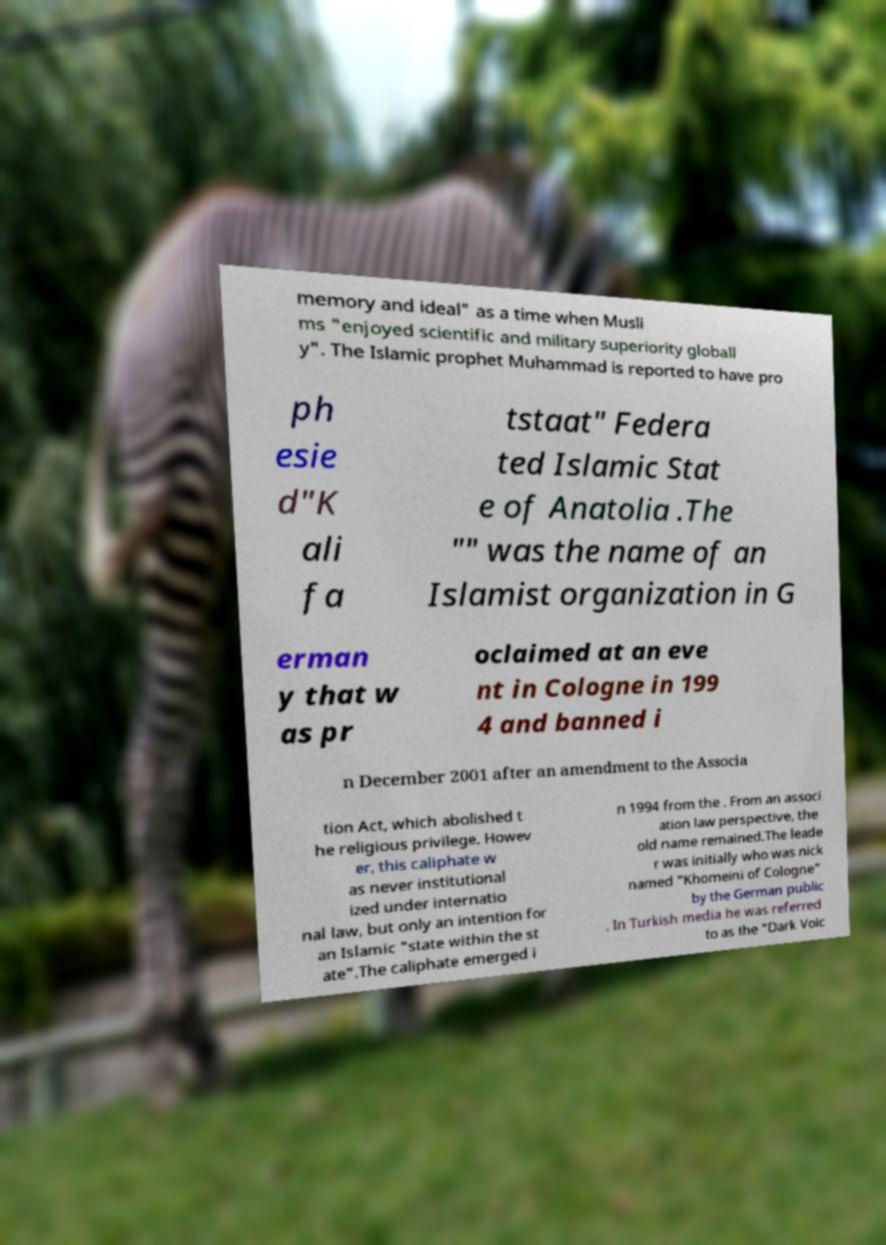There's text embedded in this image that I need extracted. Can you transcribe it verbatim? memory and ideal" as a time when Musli ms "enjoyed scientific and military superiority globall y". The Islamic prophet Muhammad is reported to have pro ph esie d"K ali fa tstaat" Federa ted Islamic Stat e of Anatolia .The "" was the name of an Islamist organization in G erman y that w as pr oclaimed at an eve nt in Cologne in 199 4 and banned i n December 2001 after an amendment to the Associa tion Act, which abolished t he religious privilege. Howev er, this caliphate w as never institutional ized under internatio nal law, but only an intention for an Islamic "state within the st ate".The caliphate emerged i n 1994 from the . From an associ ation law perspective, the old name remained.The leade r was initially who was nick named "Khomeini of Cologne" by the German public . In Turkish media he was referred to as the "Dark Voic 